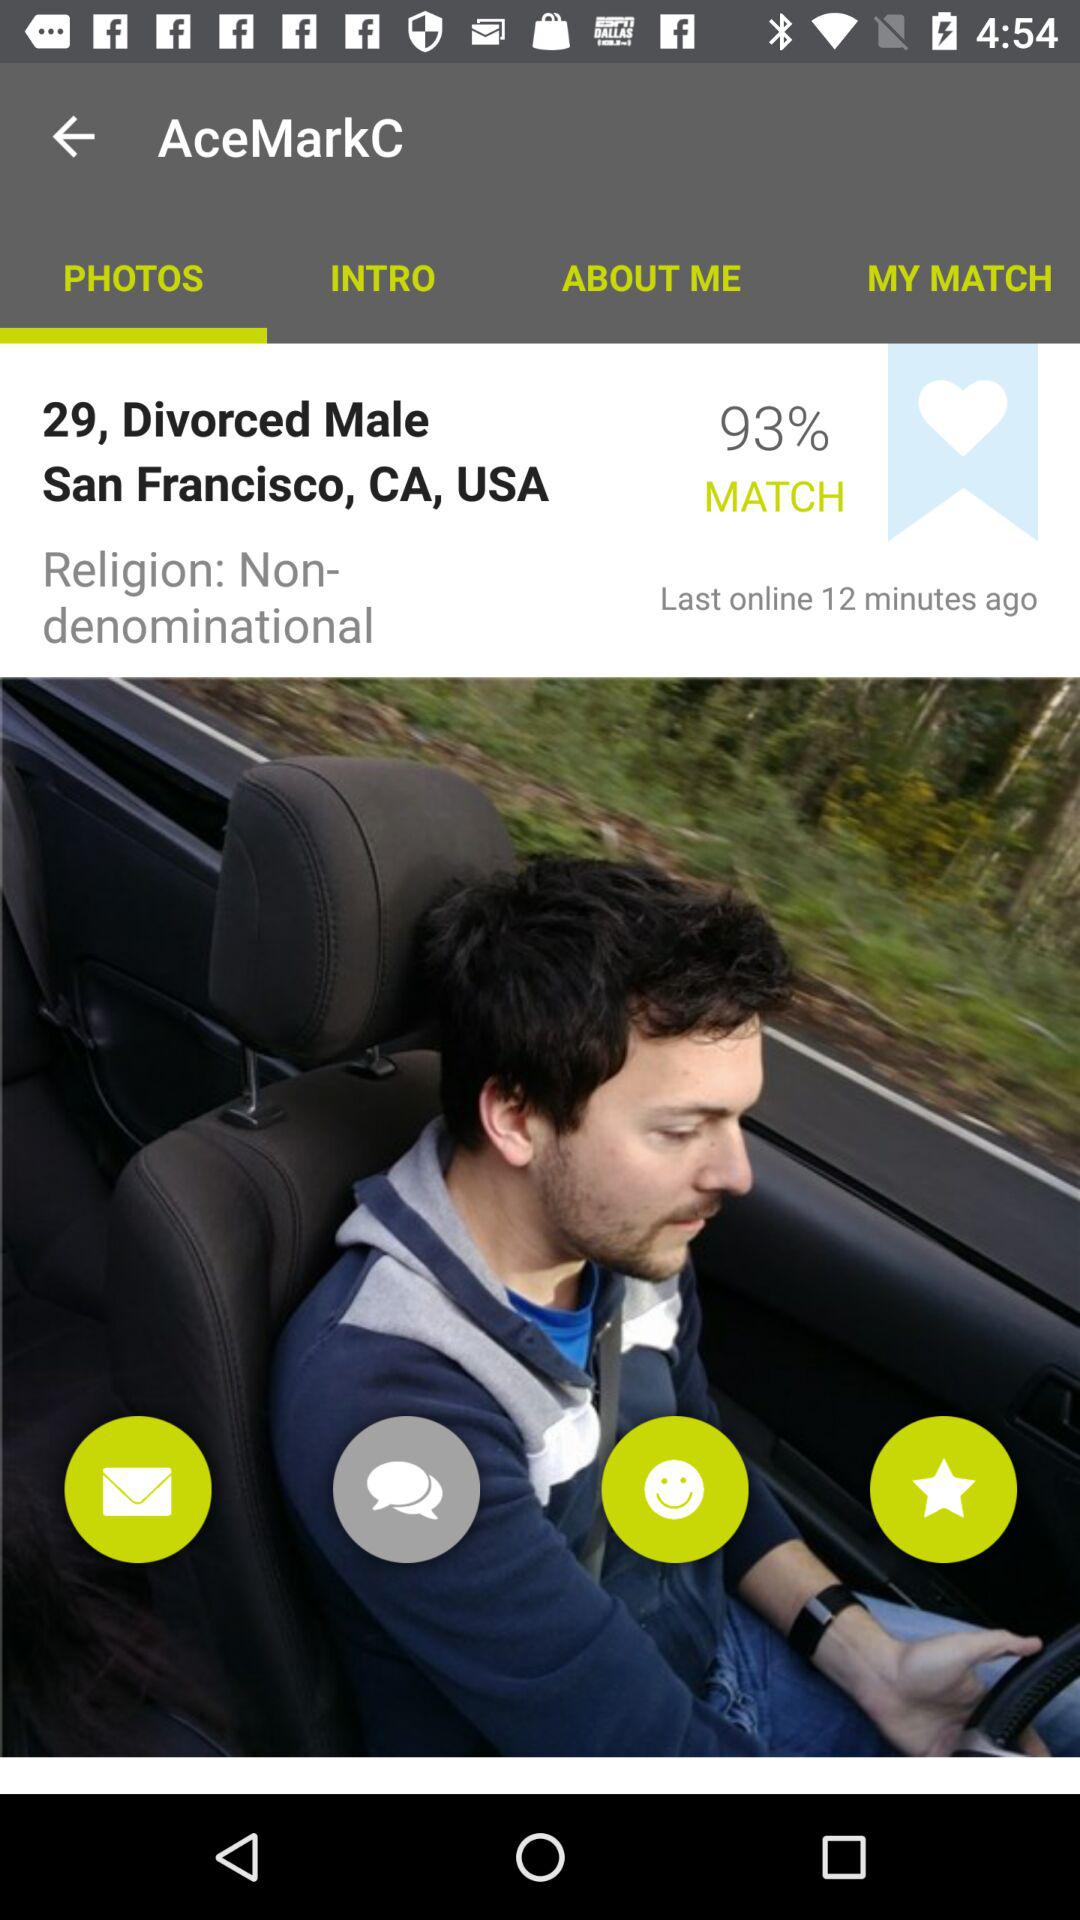What is the percentage of the match? The percentage is 93. 